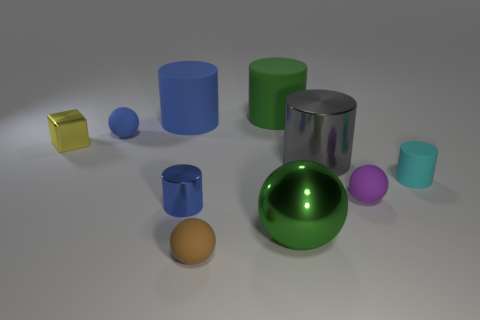There is a big thing that is the same color as the metallic sphere; what is its material?
Keep it short and to the point. Rubber. How many things are either cyan matte cylinders or small objects that are in front of the cyan cylinder?
Ensure brevity in your answer.  4. What is the material of the big green cylinder?
Provide a short and direct response. Rubber. There is a tiny cyan thing that is the same shape as the gray object; what is its material?
Your answer should be very brief. Rubber. There is a big metal thing in front of the rubber ball that is right of the big green metallic thing; what is its color?
Offer a terse response. Green. What number of metallic objects are either small cyan objects or brown spheres?
Your response must be concise. 0. Are the tiny brown ball and the yellow block made of the same material?
Keep it short and to the point. No. What is the material of the big cylinder that is left of the green object behind the tiny cube?
Provide a succinct answer. Rubber. How many small objects are blue rubber cylinders or green objects?
Ensure brevity in your answer.  0. What is the size of the green matte cylinder?
Ensure brevity in your answer.  Large. 